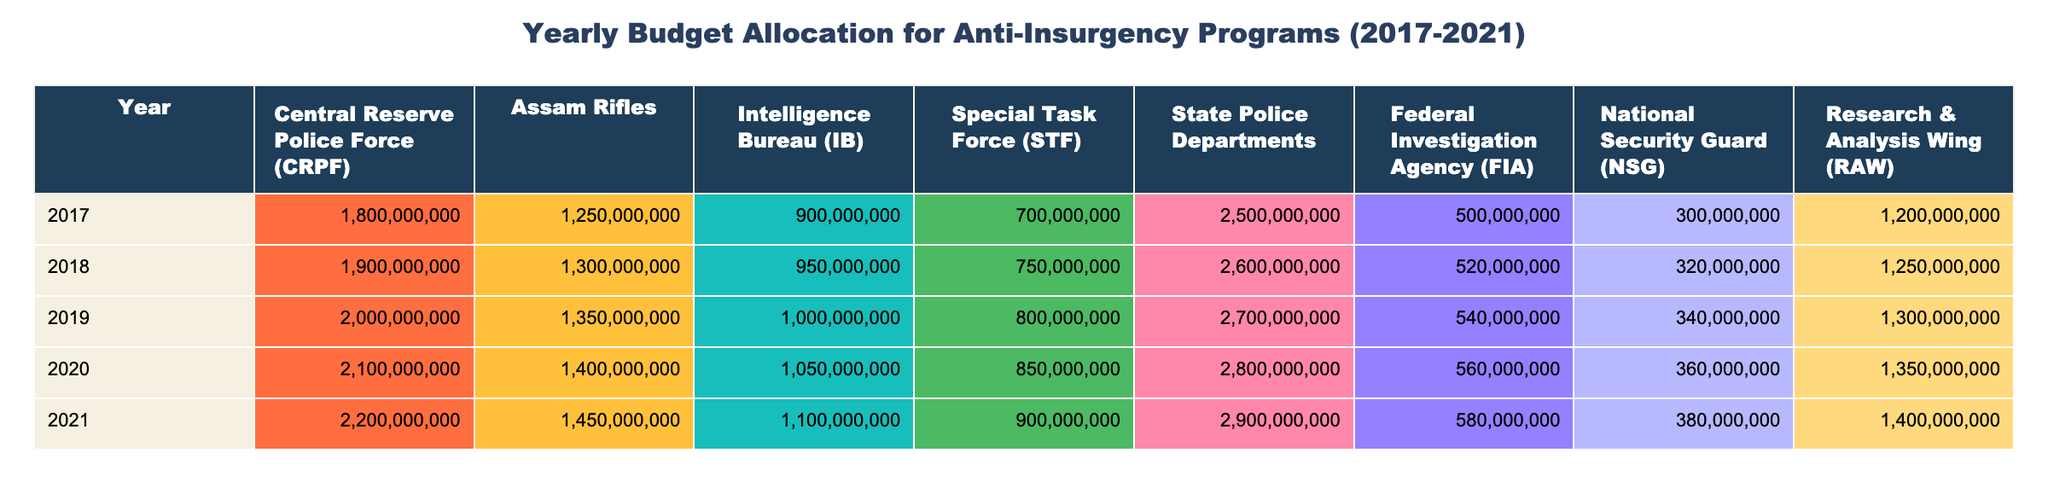What was the highest budget allocated to the Central Reserve Police Force (CRPF) during this period? By examining the values under the CRPF column for each year, the highest value is in 2021, which is 2,200,000,000.
Answer: 2,200,000,000 What is the total budget allocated to the State Police Departments from 2017 to 2021? To find the total for the State Police Departments, sum up the annual budgets: 2,500,000,000 + 2,600,000,000 + 2,700,000,000 + 2,800,000,000 + 2,900,000,000 = 13,500,000,000.
Answer: 13,500,000,000 Did the budget for the Intelligence Bureau (IB) increase every year? Looking at the IB values from 2017 to 2021, we see: 900,000,000, 950,000,000, 1,000,000,000, 1,050,000,000, and 1,100,000,000. Since all values are increasing, the budget did increase every year.
Answer: Yes What is the average annual budget allocated to the Assam Rifles over the five years? The total allocation for Assam Rifles from 2017 to 2021 is: 1,250,000,000 + 1,300,000,000 + 1,350,000,000 + 1,400,000,000 + 1,450,000,000 = 6,750,000,000. Dividing by the number of years (5) gives an average of 1,350,000,000.
Answer: 1,350,000,000 Which year saw the greatest increase in budget allocation for the National Security Guard (NSG)? To find the greatest increase, look at the differences between consecutive years: (360,000,000 - 340,000,000) in 2020, (380,000,000 - 360,000,000) in 2021. The increase from 2020 to 2021 (20,000,000) is greater compared to the previous year, which is the only increase in the time span.
Answer: 2021 What was the total budget allocated to the Research & Analysis Wing (RAW) in 2019? The value for RAW in 2019 is clearly listed in the table as 1,300,000,000.
Answer: 1,300,000,000 Which organization received the lowest budget in 2018? Reviewing the values for 2018, we see: CRPF (1,900,000,000), Assam Rifles (1,300,000,000), IB (950,000,000), STF (750,000,000), State Police Departments (2,600,000,000), FIA (520,000,000), NSG (320,000,000), and RAW (1,250,000,000). The organization with the lowest budget in that year is the NSG.
Answer: NSG What is the overall increase in budget allocation for the Special Task Force (STF) from 2017 to 2021? The STF allocation in 2017 was 700,000,000 and in 2021 it was 900,000,000. The increase is calculated as 900,000,000 - 700,000,000 = 200,000,000.
Answer: 200,000,000 In which year did the Assam Rifles first exceed a budget of 1,400,000,000? By scanning through the values for Assam Rifles, we find that the first amount exceeding 1,400,000,000 occurs in 2020 (1,400,000,000), thus this is the year in question.
Answer: 2020 